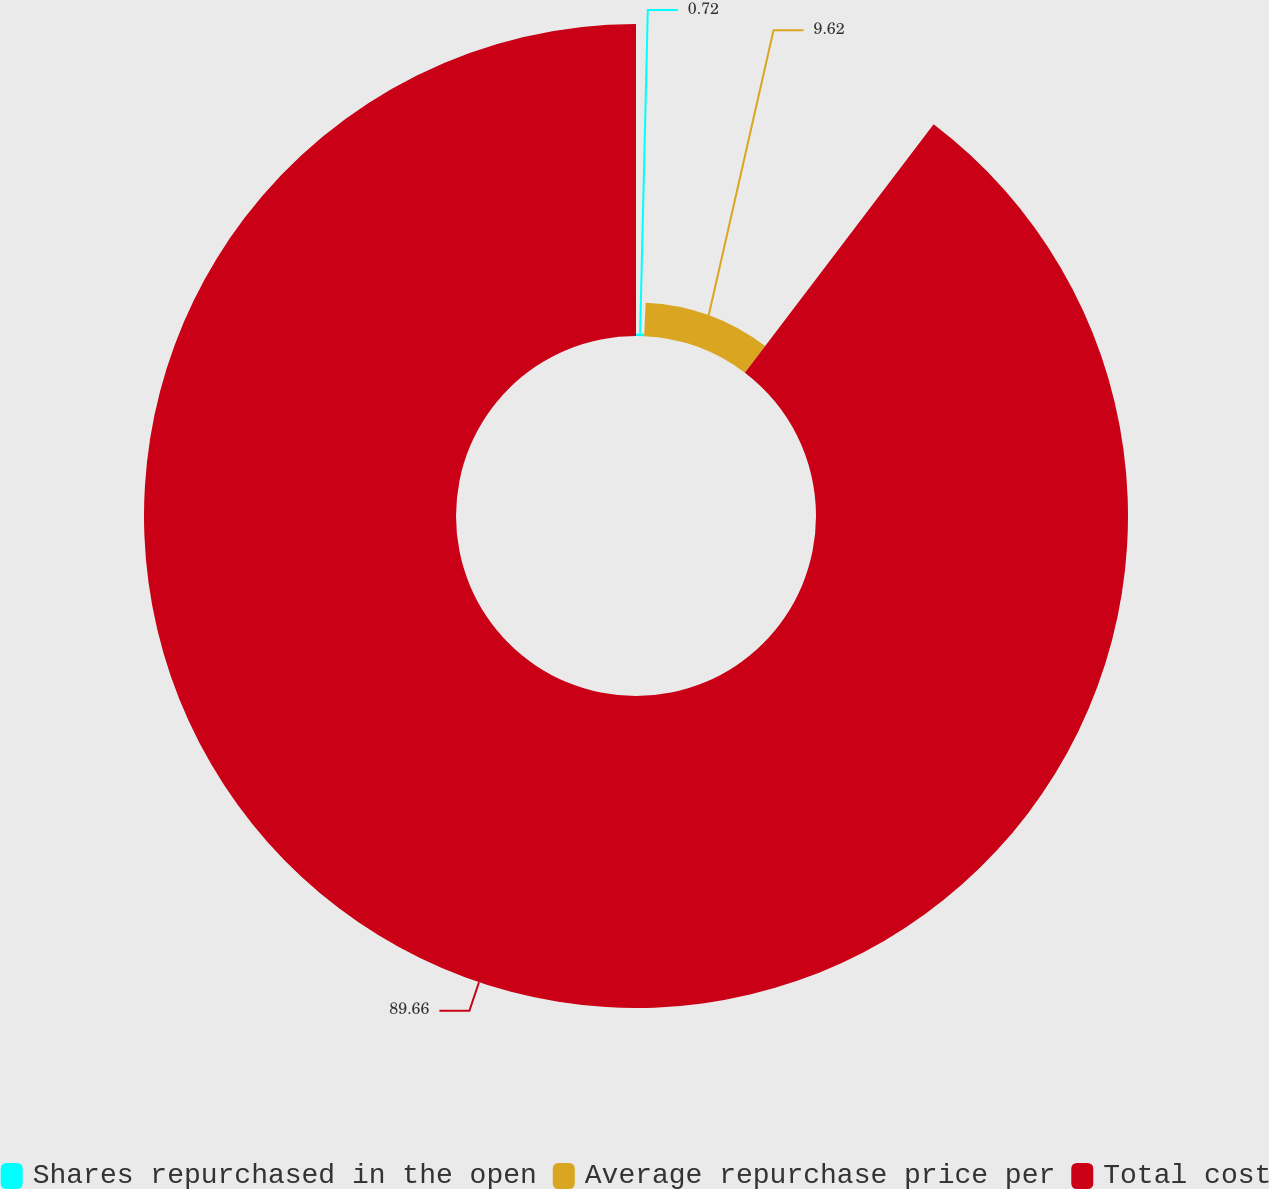Convert chart. <chart><loc_0><loc_0><loc_500><loc_500><pie_chart><fcel>Shares repurchased in the open<fcel>Average repurchase price per<fcel>Total cost<nl><fcel>0.72%<fcel>9.62%<fcel>89.66%<nl></chart> 